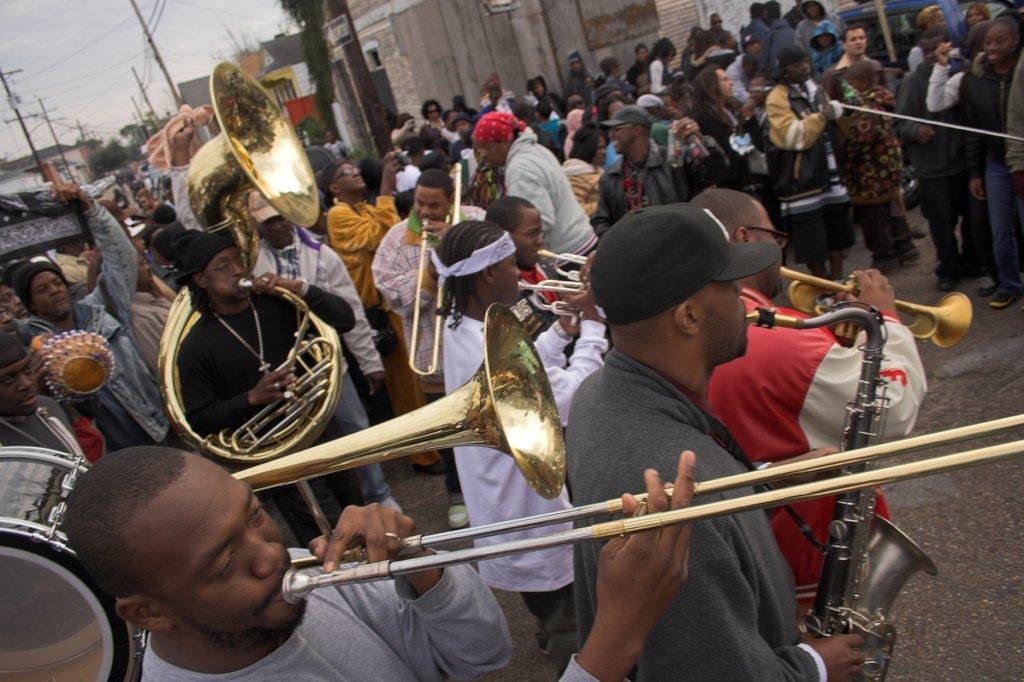Please provide a concise description of this image. This is the picture of a city. In the foreground there are group of people standing and playing musical instruments. At the back there are group of people. At the back there are buildings, trees and poles and there are wires on the poles. At the top there is sky. At the bottom there is a road. 